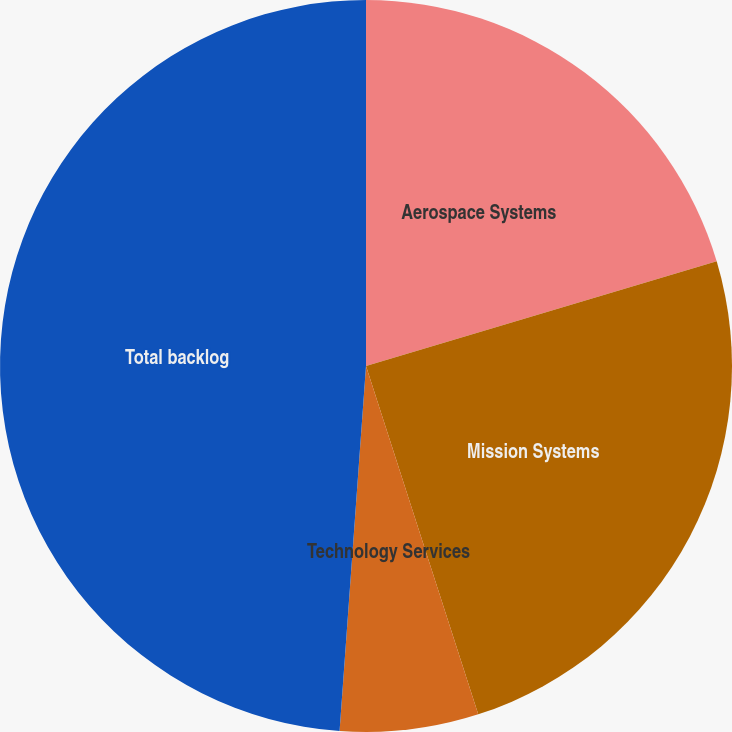<chart> <loc_0><loc_0><loc_500><loc_500><pie_chart><fcel>Aerospace Systems<fcel>Mission Systems<fcel>Technology Services<fcel>Total backlog<nl><fcel>20.38%<fcel>24.66%<fcel>6.11%<fcel>48.85%<nl></chart> 